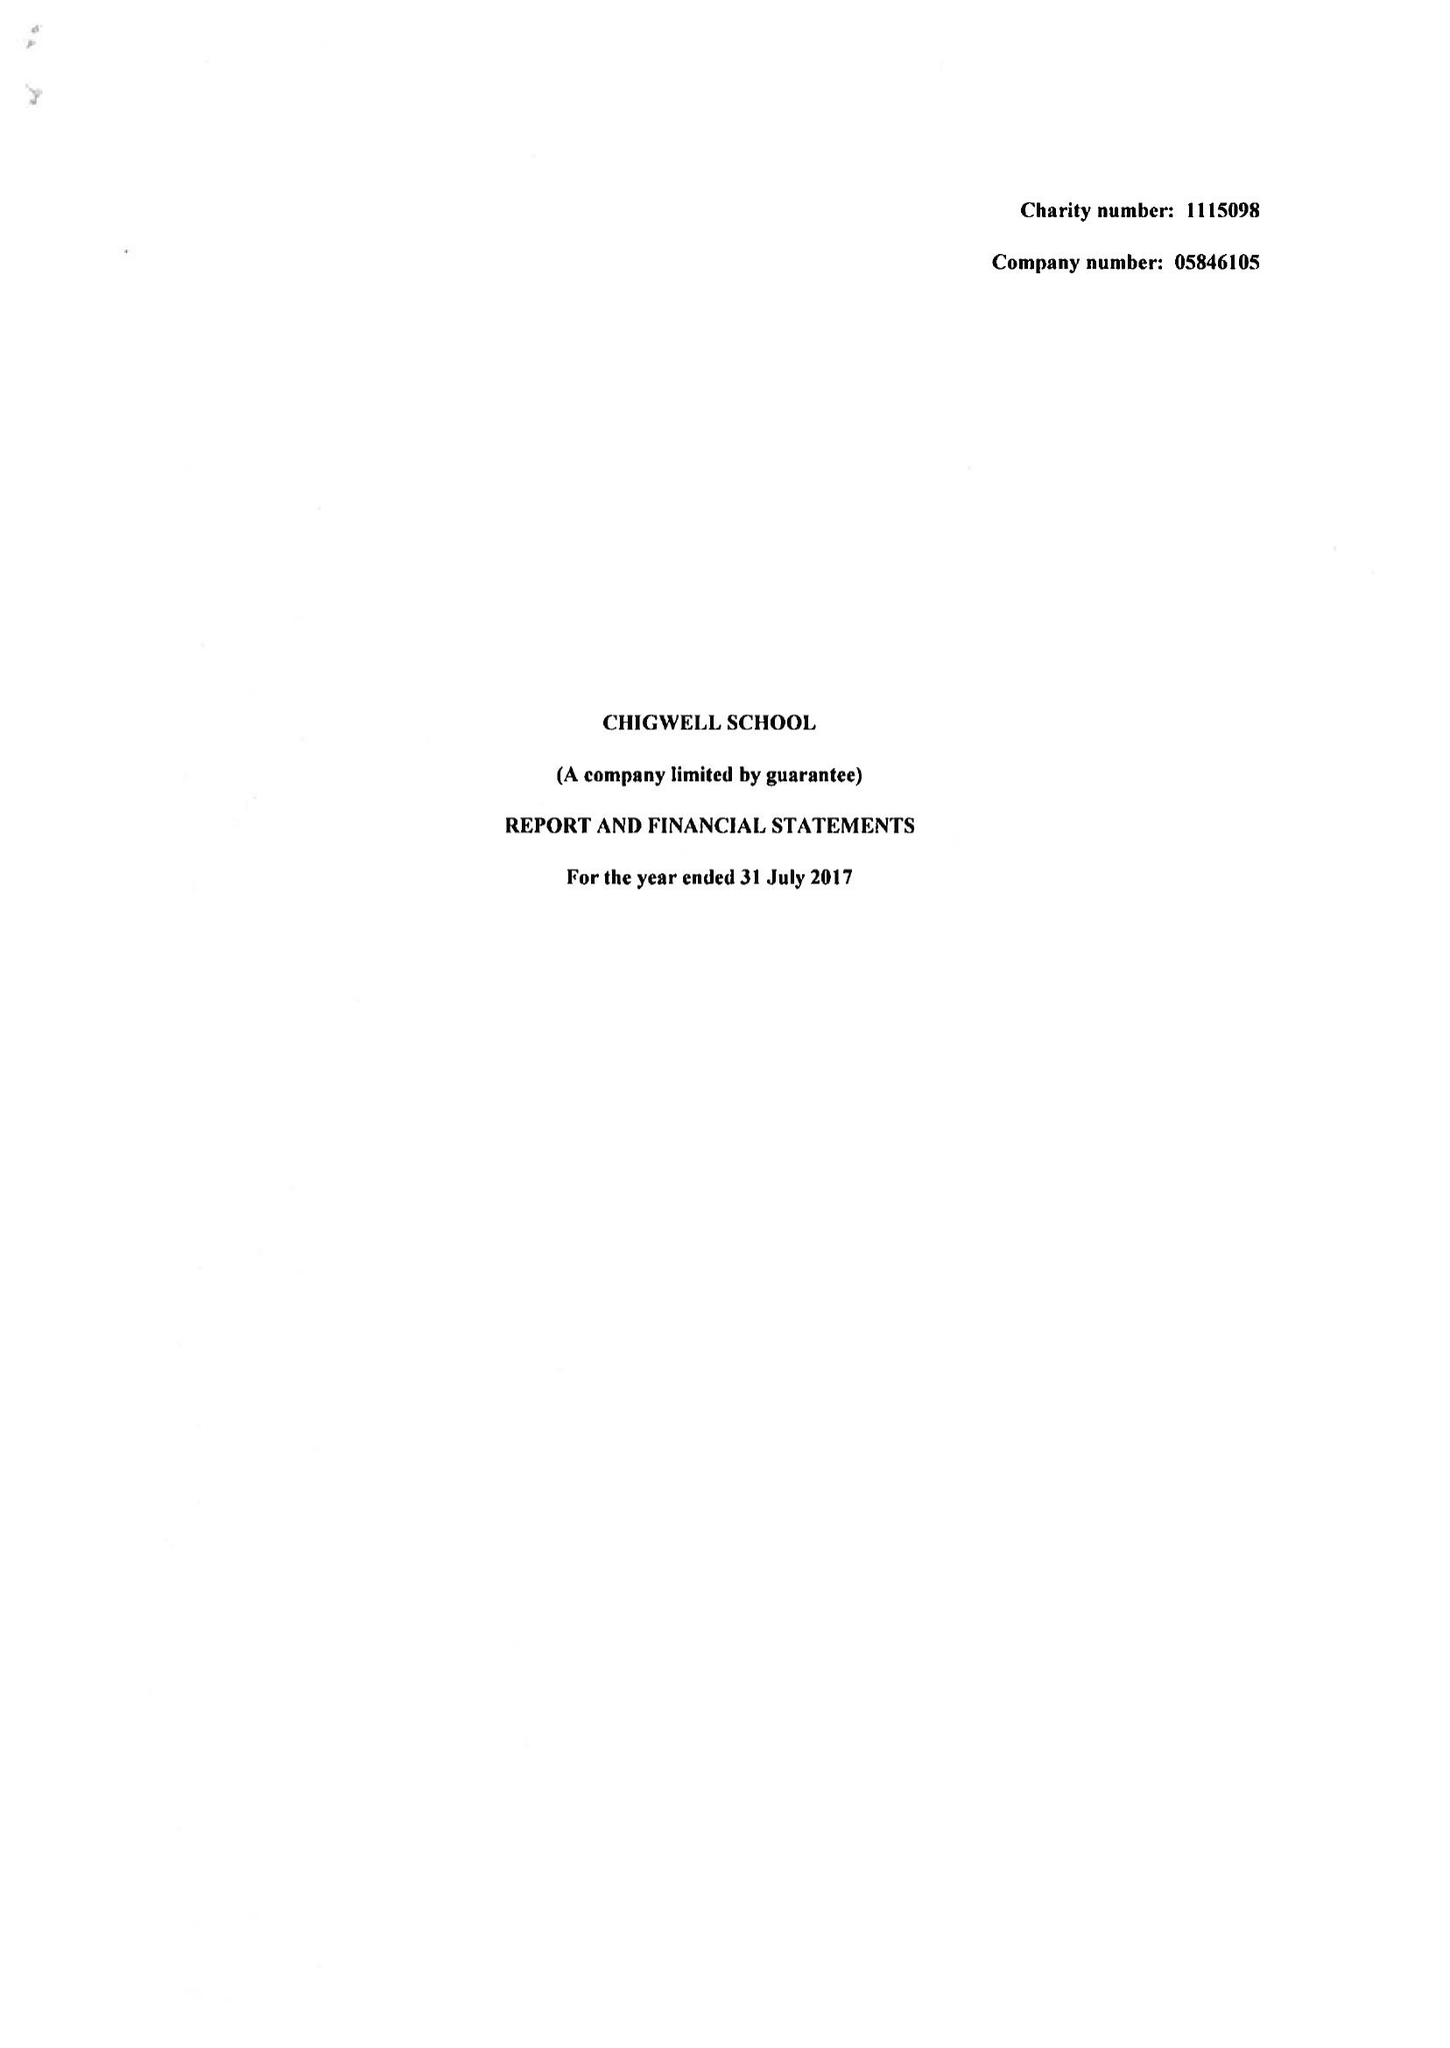What is the value for the spending_annually_in_british_pounds?
Answer the question using a single word or phrase. 12460909.00 